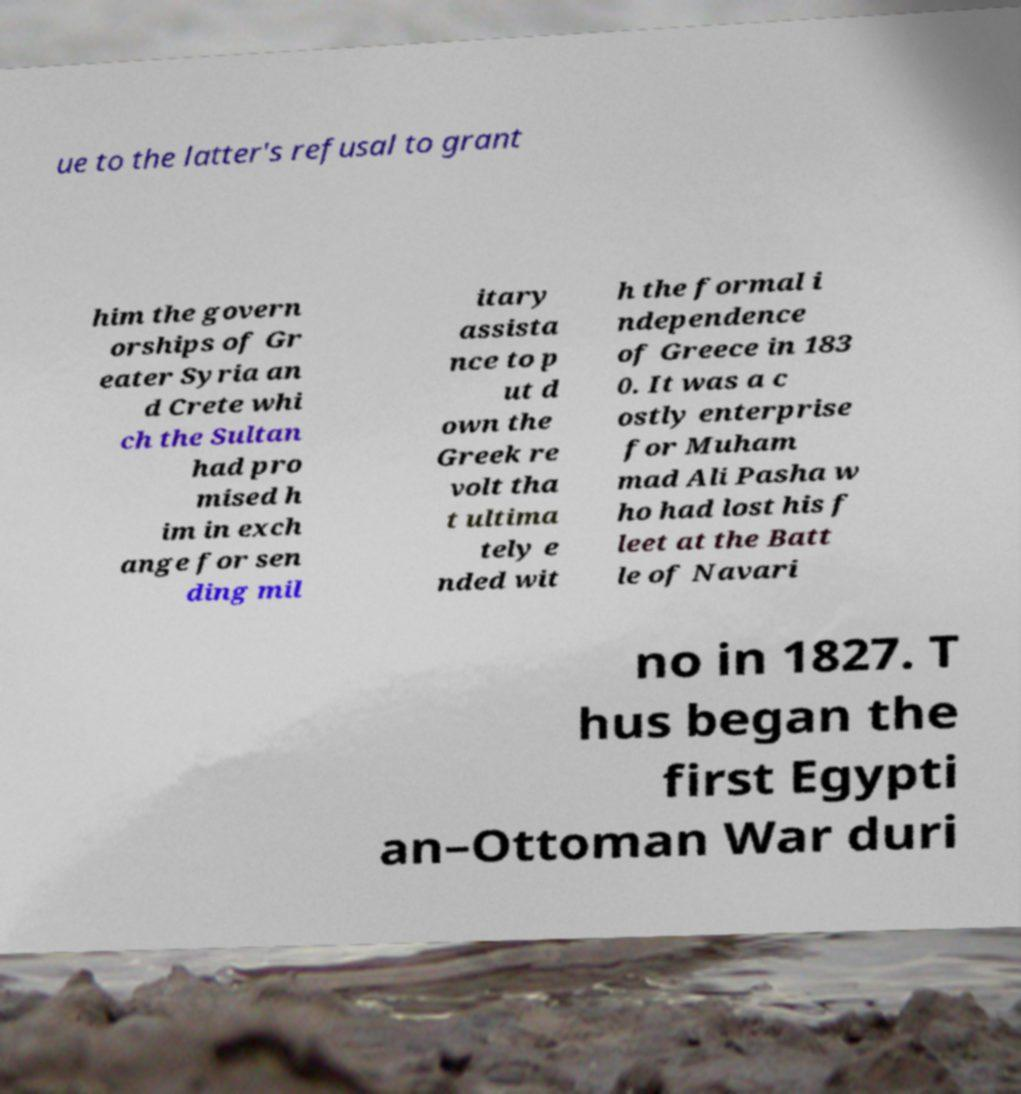There's text embedded in this image that I need extracted. Can you transcribe it verbatim? ue to the latter's refusal to grant him the govern orships of Gr eater Syria an d Crete whi ch the Sultan had pro mised h im in exch ange for sen ding mil itary assista nce to p ut d own the Greek re volt tha t ultima tely e nded wit h the formal i ndependence of Greece in 183 0. It was a c ostly enterprise for Muham mad Ali Pasha w ho had lost his f leet at the Batt le of Navari no in 1827. T hus began the first Egypti an–Ottoman War duri 